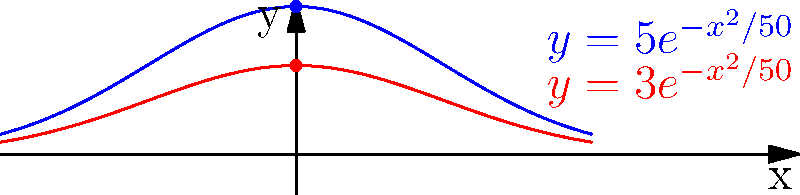In a workplace accident, two hazardous materials were spilled, creating contamination gradients that can be modeled by the functions $y=5e^{-x^2/50}$ and $y=3e^{-x^2/50}$, where $y$ represents the concentration level (in parts per million) and $x$ represents the distance (in meters) from the spill center. To determine the total affected area, we need to calculate the area between these two curves. What is the total affected area in square meters, rounded to the nearest whole number? To find the area between the two curves, we need to:

1. Determine the region of integration:
   The curves intersect when $5e^{-x^2/50} = 3e^{-x^2/50}$
   This occurs at $x = \pm \sqrt{50 \ln(5/3)} \approx \pm 5.13$ meters

2. Set up the integral:
   Area = $\int_{-5.13}^{5.13} (5e^{-x^2/50} - 3e^{-x^2/50}) dx$

3. Simplify the integrand:
   Area = $\int_{-5.13}^{5.13} 2e^{-x^2/50} dx$

4. Use the substitution method:
   Let $u = x/\sqrt{50}$, then $dx = \sqrt{50} du$
   New limits: $u = \pm 5.13/\sqrt{50} \approx \pm 0.725$

   Area = $2\sqrt{50} \int_{-0.725}^{0.725} e^{-u^2} du$

5. This integral is related to the error function (erf):
   Area = $2\sqrt{50} \cdot \frac{\sqrt{\pi}}{2} \cdot \text{erf}(0.725)$

6. Calculate:
   Area = $\sqrt{50\pi} \cdot \text{erf}(0.725)$
   $\approx 12.53 \cdot 0.7063$
   $\approx 8.85$ square meters

7. Round to the nearest whole number:
   Area ≈ 9 square meters
Answer: 9 square meters 